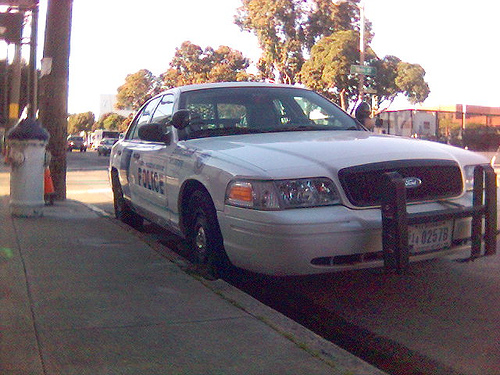Please transcribe the text information in this image. 02578 